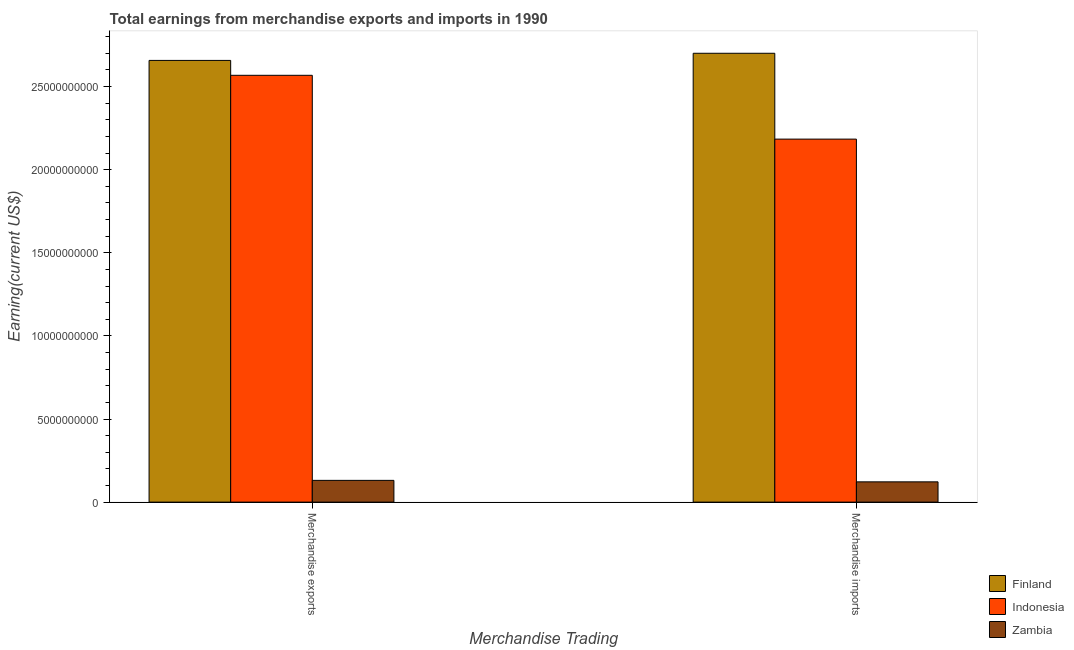Are the number of bars on each tick of the X-axis equal?
Your response must be concise. Yes. What is the earnings from merchandise imports in Indonesia?
Your answer should be compact. 2.18e+1. Across all countries, what is the maximum earnings from merchandise imports?
Your response must be concise. 2.70e+1. Across all countries, what is the minimum earnings from merchandise exports?
Your answer should be very brief. 1.31e+09. In which country was the earnings from merchandise exports maximum?
Ensure brevity in your answer.  Finland. In which country was the earnings from merchandise imports minimum?
Your response must be concise. Zambia. What is the total earnings from merchandise exports in the graph?
Your response must be concise. 5.36e+1. What is the difference between the earnings from merchandise exports in Finland and that in Indonesia?
Ensure brevity in your answer.  8.96e+08. What is the difference between the earnings from merchandise imports in Indonesia and the earnings from merchandise exports in Finland?
Provide a succinct answer. -4.73e+09. What is the average earnings from merchandise imports per country?
Offer a very short reply. 1.67e+1. What is the difference between the earnings from merchandise exports and earnings from merchandise imports in Finland?
Provide a short and direct response. -4.30e+08. In how many countries, is the earnings from merchandise exports greater than 9000000000 US$?
Ensure brevity in your answer.  2. What is the ratio of the earnings from merchandise exports in Indonesia to that in Zambia?
Give a very brief answer. 19.61. Is the earnings from merchandise imports in Indonesia less than that in Finland?
Provide a succinct answer. Yes. In how many countries, is the earnings from merchandise exports greater than the average earnings from merchandise exports taken over all countries?
Ensure brevity in your answer.  2. What does the 3rd bar from the left in Merchandise exports represents?
Keep it short and to the point. Zambia. What does the 3rd bar from the right in Merchandise exports represents?
Give a very brief answer. Finland. How many bars are there?
Offer a very short reply. 6. Are all the bars in the graph horizontal?
Make the answer very short. No. How many countries are there in the graph?
Give a very brief answer. 3. What is the difference between two consecutive major ticks on the Y-axis?
Ensure brevity in your answer.  5.00e+09. Are the values on the major ticks of Y-axis written in scientific E-notation?
Provide a succinct answer. No. Where does the legend appear in the graph?
Provide a succinct answer. Bottom right. How many legend labels are there?
Provide a succinct answer. 3. How are the legend labels stacked?
Make the answer very short. Vertical. What is the title of the graph?
Your answer should be compact. Total earnings from merchandise exports and imports in 1990. Does "French Polynesia" appear as one of the legend labels in the graph?
Your answer should be compact. No. What is the label or title of the X-axis?
Your answer should be compact. Merchandise Trading. What is the label or title of the Y-axis?
Your response must be concise. Earning(current US$). What is the Earning(current US$) of Finland in Merchandise exports?
Keep it short and to the point. 2.66e+1. What is the Earning(current US$) of Indonesia in Merchandise exports?
Make the answer very short. 2.57e+1. What is the Earning(current US$) in Zambia in Merchandise exports?
Make the answer very short. 1.31e+09. What is the Earning(current US$) in Finland in Merchandise imports?
Your answer should be compact. 2.70e+1. What is the Earning(current US$) in Indonesia in Merchandise imports?
Keep it short and to the point. 2.18e+1. What is the Earning(current US$) in Zambia in Merchandise imports?
Your answer should be very brief. 1.22e+09. Across all Merchandise Trading, what is the maximum Earning(current US$) of Finland?
Your answer should be compact. 2.70e+1. Across all Merchandise Trading, what is the maximum Earning(current US$) in Indonesia?
Make the answer very short. 2.57e+1. Across all Merchandise Trading, what is the maximum Earning(current US$) in Zambia?
Offer a terse response. 1.31e+09. Across all Merchandise Trading, what is the minimum Earning(current US$) of Finland?
Your answer should be very brief. 2.66e+1. Across all Merchandise Trading, what is the minimum Earning(current US$) in Indonesia?
Provide a short and direct response. 2.18e+1. Across all Merchandise Trading, what is the minimum Earning(current US$) in Zambia?
Your response must be concise. 1.22e+09. What is the total Earning(current US$) of Finland in the graph?
Provide a short and direct response. 5.36e+1. What is the total Earning(current US$) in Indonesia in the graph?
Offer a very short reply. 4.75e+1. What is the total Earning(current US$) in Zambia in the graph?
Your answer should be compact. 2.53e+09. What is the difference between the Earning(current US$) of Finland in Merchandise exports and that in Merchandise imports?
Provide a short and direct response. -4.30e+08. What is the difference between the Earning(current US$) of Indonesia in Merchandise exports and that in Merchandise imports?
Ensure brevity in your answer.  3.84e+09. What is the difference between the Earning(current US$) in Zambia in Merchandise exports and that in Merchandise imports?
Your response must be concise. 8.90e+07. What is the difference between the Earning(current US$) in Finland in Merchandise exports and the Earning(current US$) in Indonesia in Merchandise imports?
Keep it short and to the point. 4.73e+09. What is the difference between the Earning(current US$) of Finland in Merchandise exports and the Earning(current US$) of Zambia in Merchandise imports?
Make the answer very short. 2.54e+1. What is the difference between the Earning(current US$) in Indonesia in Merchandise exports and the Earning(current US$) in Zambia in Merchandise imports?
Provide a succinct answer. 2.45e+1. What is the average Earning(current US$) of Finland per Merchandise Trading?
Ensure brevity in your answer.  2.68e+1. What is the average Earning(current US$) in Indonesia per Merchandise Trading?
Your answer should be compact. 2.38e+1. What is the average Earning(current US$) of Zambia per Merchandise Trading?
Offer a very short reply. 1.26e+09. What is the difference between the Earning(current US$) in Finland and Earning(current US$) in Indonesia in Merchandise exports?
Your answer should be very brief. 8.96e+08. What is the difference between the Earning(current US$) in Finland and Earning(current US$) in Zambia in Merchandise exports?
Your response must be concise. 2.53e+1. What is the difference between the Earning(current US$) in Indonesia and Earning(current US$) in Zambia in Merchandise exports?
Provide a short and direct response. 2.44e+1. What is the difference between the Earning(current US$) in Finland and Earning(current US$) in Indonesia in Merchandise imports?
Give a very brief answer. 5.16e+09. What is the difference between the Earning(current US$) of Finland and Earning(current US$) of Zambia in Merchandise imports?
Keep it short and to the point. 2.58e+1. What is the difference between the Earning(current US$) of Indonesia and Earning(current US$) of Zambia in Merchandise imports?
Your response must be concise. 2.06e+1. What is the ratio of the Earning(current US$) of Finland in Merchandise exports to that in Merchandise imports?
Your answer should be compact. 0.98. What is the ratio of the Earning(current US$) in Indonesia in Merchandise exports to that in Merchandise imports?
Ensure brevity in your answer.  1.18. What is the ratio of the Earning(current US$) in Zambia in Merchandise exports to that in Merchandise imports?
Make the answer very short. 1.07. What is the difference between the highest and the second highest Earning(current US$) of Finland?
Keep it short and to the point. 4.30e+08. What is the difference between the highest and the second highest Earning(current US$) in Indonesia?
Provide a succinct answer. 3.84e+09. What is the difference between the highest and the second highest Earning(current US$) in Zambia?
Your answer should be very brief. 8.90e+07. What is the difference between the highest and the lowest Earning(current US$) in Finland?
Offer a terse response. 4.30e+08. What is the difference between the highest and the lowest Earning(current US$) in Indonesia?
Your answer should be very brief. 3.84e+09. What is the difference between the highest and the lowest Earning(current US$) in Zambia?
Provide a succinct answer. 8.90e+07. 